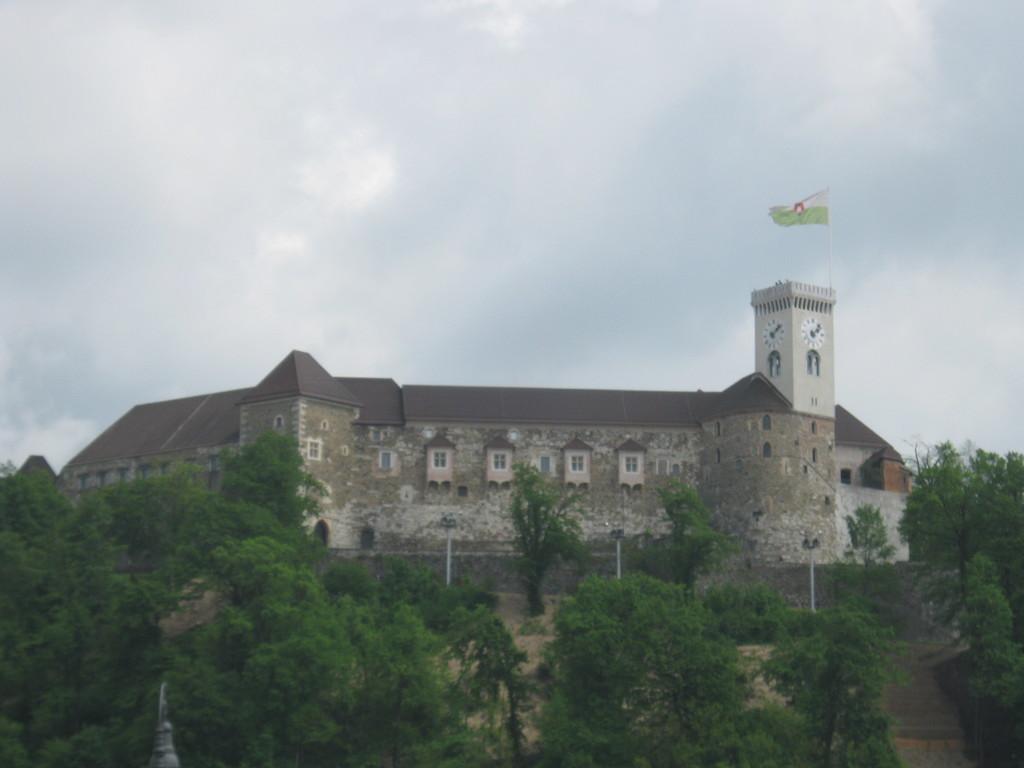In one or two sentences, can you explain what this image depicts? In this image in front there are trees. In the center of the image there is a building. There is a flag and in the background of the image there is sky. 